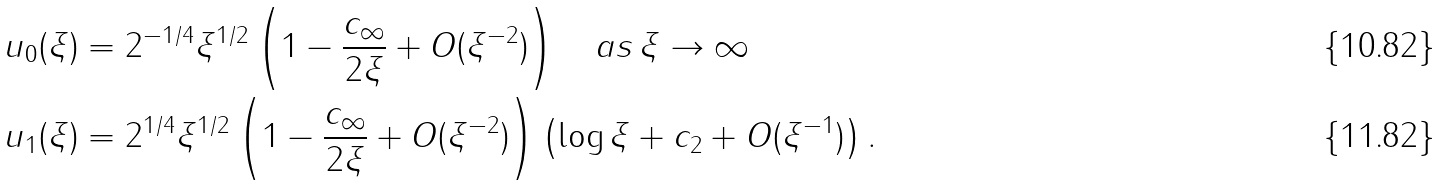<formula> <loc_0><loc_0><loc_500><loc_500>u _ { 0 } ( \xi ) & = 2 ^ { - 1 / 4 } \xi ^ { 1 / 2 } \left ( 1 - \frac { c _ { \infty } } { 2 \xi } + O ( \xi ^ { - 2 } ) \right ) \quad a s \, \xi \to \infty \\ u _ { 1 } ( \xi ) & = 2 ^ { 1 / 4 } \xi ^ { 1 / 2 } \left ( 1 - \frac { c _ { \infty } } { 2 \xi } + O ( \xi ^ { - 2 } ) \right ) \left ( \log \xi + c _ { 2 } + O ( \xi ^ { - 1 } ) \right ) .</formula> 